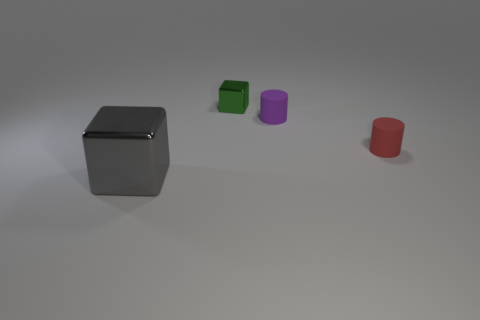Can you describe the lighting and shadows in the image? The lighting seems to be coming from the upper left, casting soft shadows to the right of the objects. The intensity of the shadows suggests a diffused light source, contributing to the overall muted tone of the scene. 